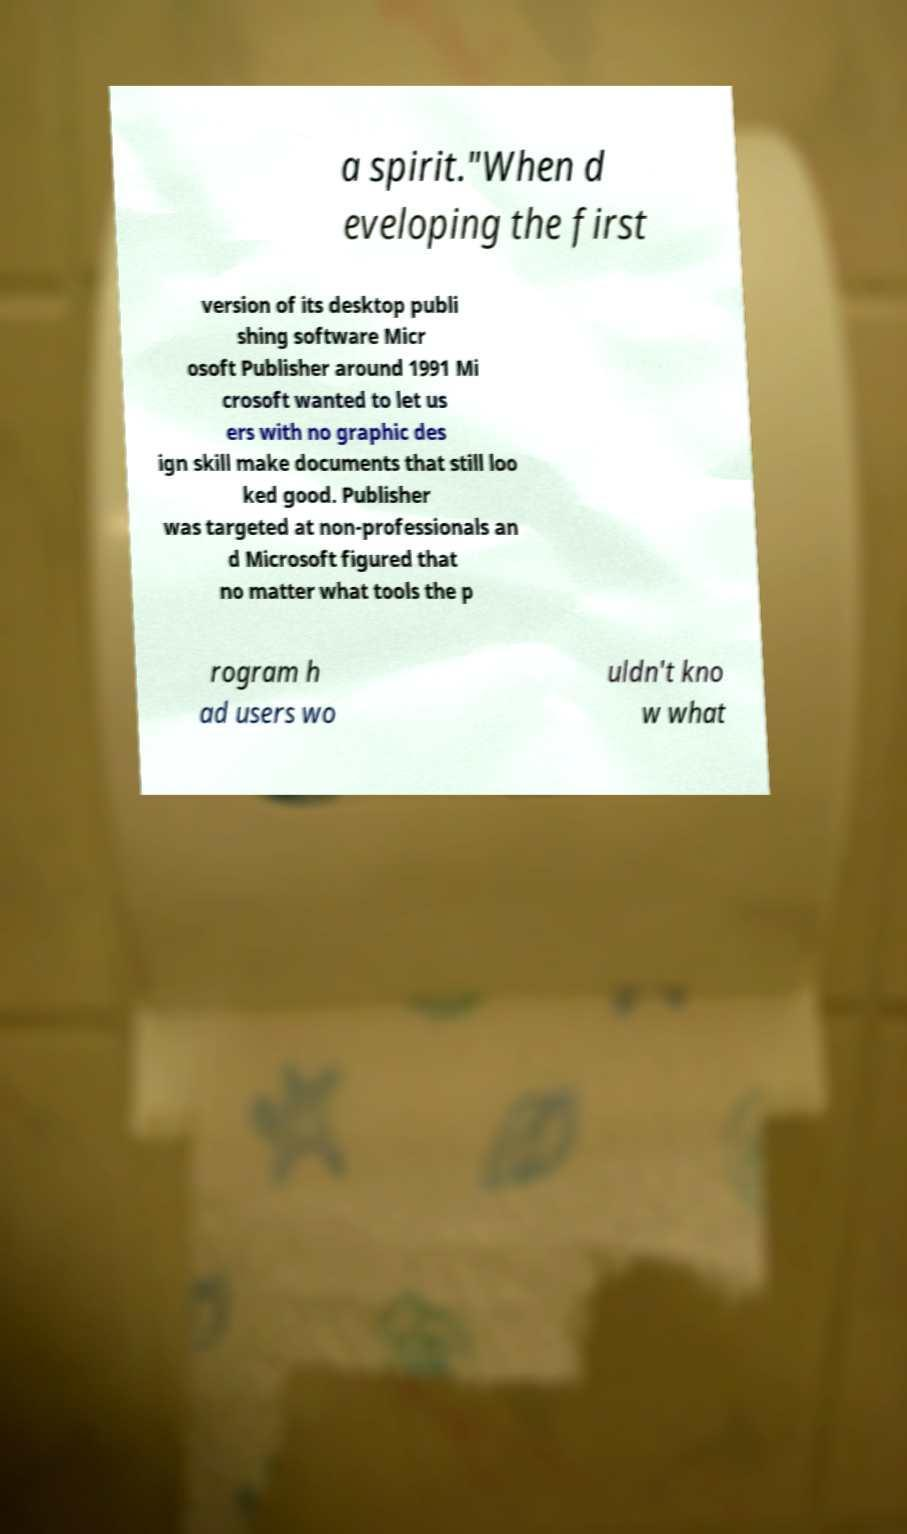There's text embedded in this image that I need extracted. Can you transcribe it verbatim? a spirit."When d eveloping the first version of its desktop publi shing software Micr osoft Publisher around 1991 Mi crosoft wanted to let us ers with no graphic des ign skill make documents that still loo ked good. Publisher was targeted at non-professionals an d Microsoft figured that no matter what tools the p rogram h ad users wo uldn't kno w what 